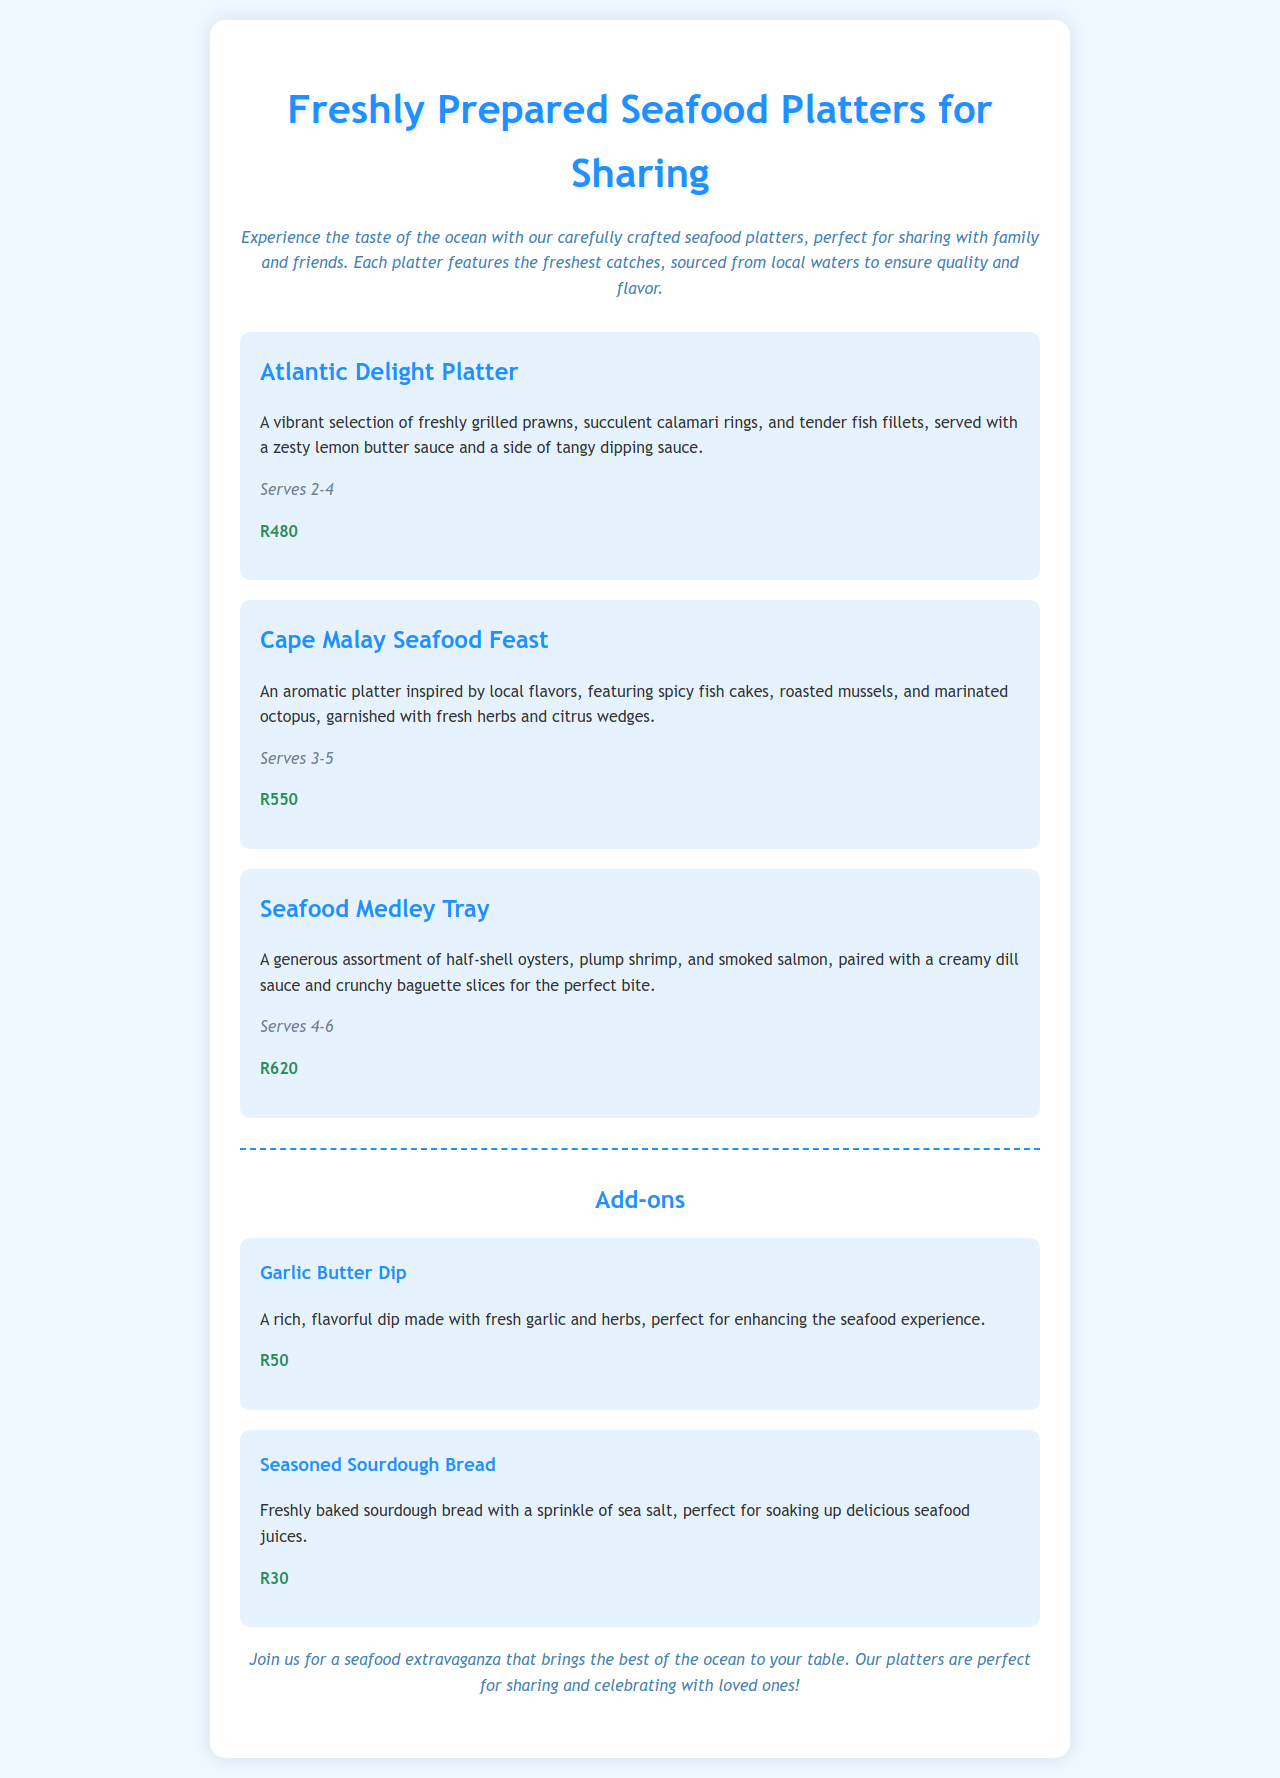What is the price of the Atlantic Delight Platter? The price is stated clearly in the document under the Atlantic Delight Platter section.
Answer: R480 How many people does the Seafood Medley Tray serve? The serving size is mentioned in the description of the Seafood Medley Tray.
Answer: Serves 4-6 What is included in the Cape Malay Seafood Feast? The platter includes spicy fish cakes, roasted mussels, and marinated octopus, as per the description.
Answer: Spicy fish cakes, roasted mussels, marinated octopus What is the total price for all add-ons? The total price can be calculated by adding the prices of Garlic Butter Dip and Seasoned Sourdough Bread.
Answer: R80 What flavor is the Garlic Butter Dip made with? The description clearly states that the dip is made with fresh garlic and herbs.
Answer: Fresh garlic and herbs Which seafood platter has the highest serving size? The serving sizes can be compared to determine which platter serves the most people.
Answer: Seafood Medley Tray What kind of bread is offered as an add-on? The document specifies the type of bread included in the add-ons section.
Answer: Seasoned Sourdough Bread What is the theme of the Seafood Medley Tray? By analyzing the description, we can identify the key components and theme associated with the platter.
Answer: Assortment of seafood 